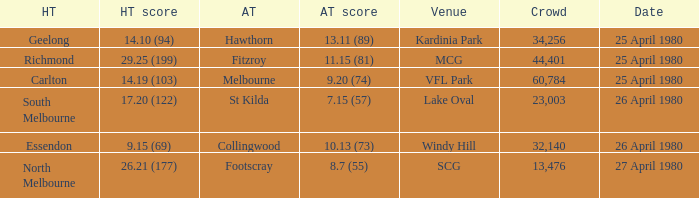What was the lowest crowd size at MCG? 44401.0. 